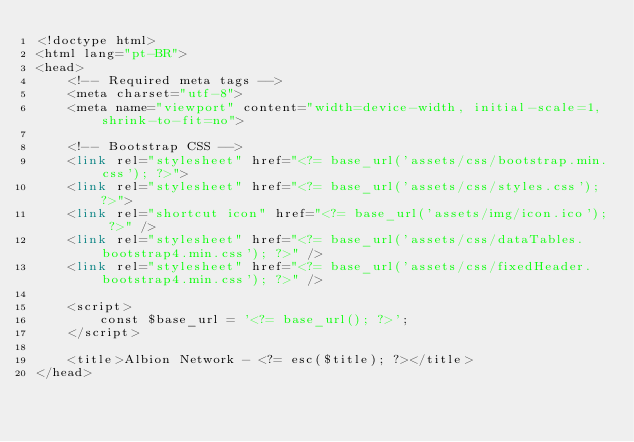Convert code to text. <code><loc_0><loc_0><loc_500><loc_500><_PHP_><!doctype html>
<html lang="pt-BR">
<head>
    <!-- Required meta tags -->
    <meta charset="utf-8">
    <meta name="viewport" content="width=device-width, initial-scale=1, shrink-to-fit=no">

    <!-- Bootstrap CSS -->
    <link rel="stylesheet" href="<?= base_url('assets/css/bootstrap.min.css'); ?>">
    <link rel="stylesheet" href="<?= base_url('assets/css/styles.css'); ?>">
    <link rel="shortcut icon" href="<?= base_url('assets/img/icon.ico'); ?>" />
    <link rel="stylesheet" href="<?= base_url('assets/css/dataTables.bootstrap4.min.css'); ?>" />
    <link rel="stylesheet" href="<?= base_url('assets/css/fixedHeader.bootstrap4.min.css'); ?>" />

    <script>
        const $base_url = '<?= base_url(); ?>';
    </script>

    <title>Albion Network - <?= esc($title); ?></title>
</head></code> 